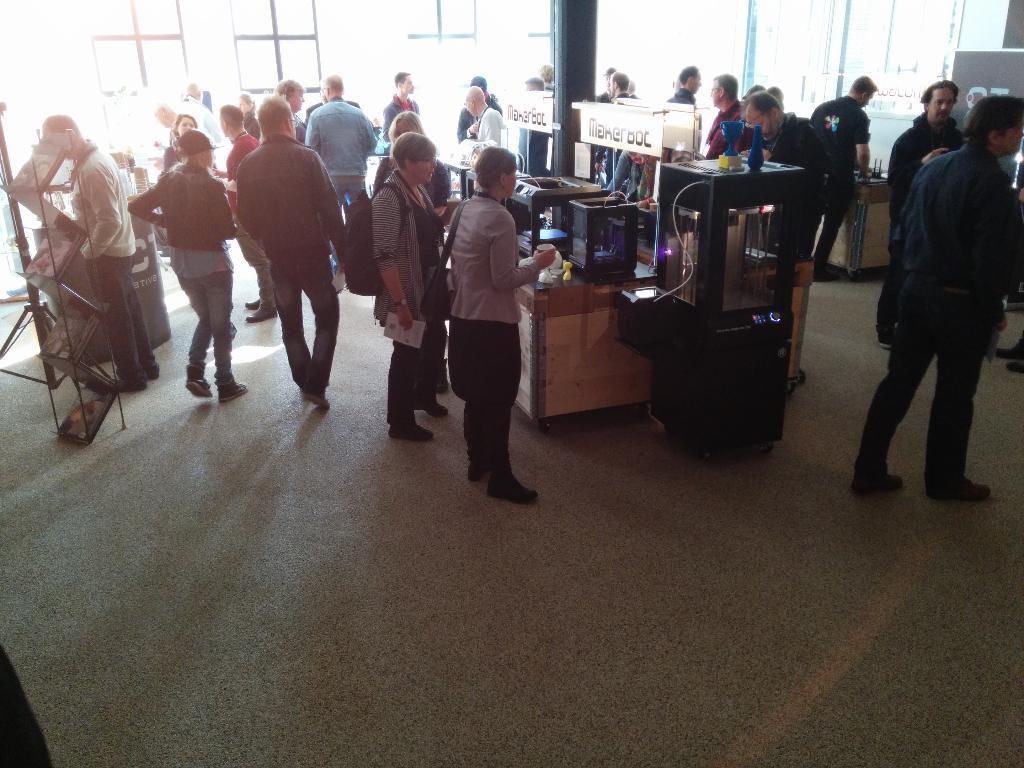In one or two sentences, can you explain what this image depicts? In this image we can see people standing and there are tables. We can see things placed on the tables. On the left there is a stand and we can see books placed in the stand. In the background there are windows. 